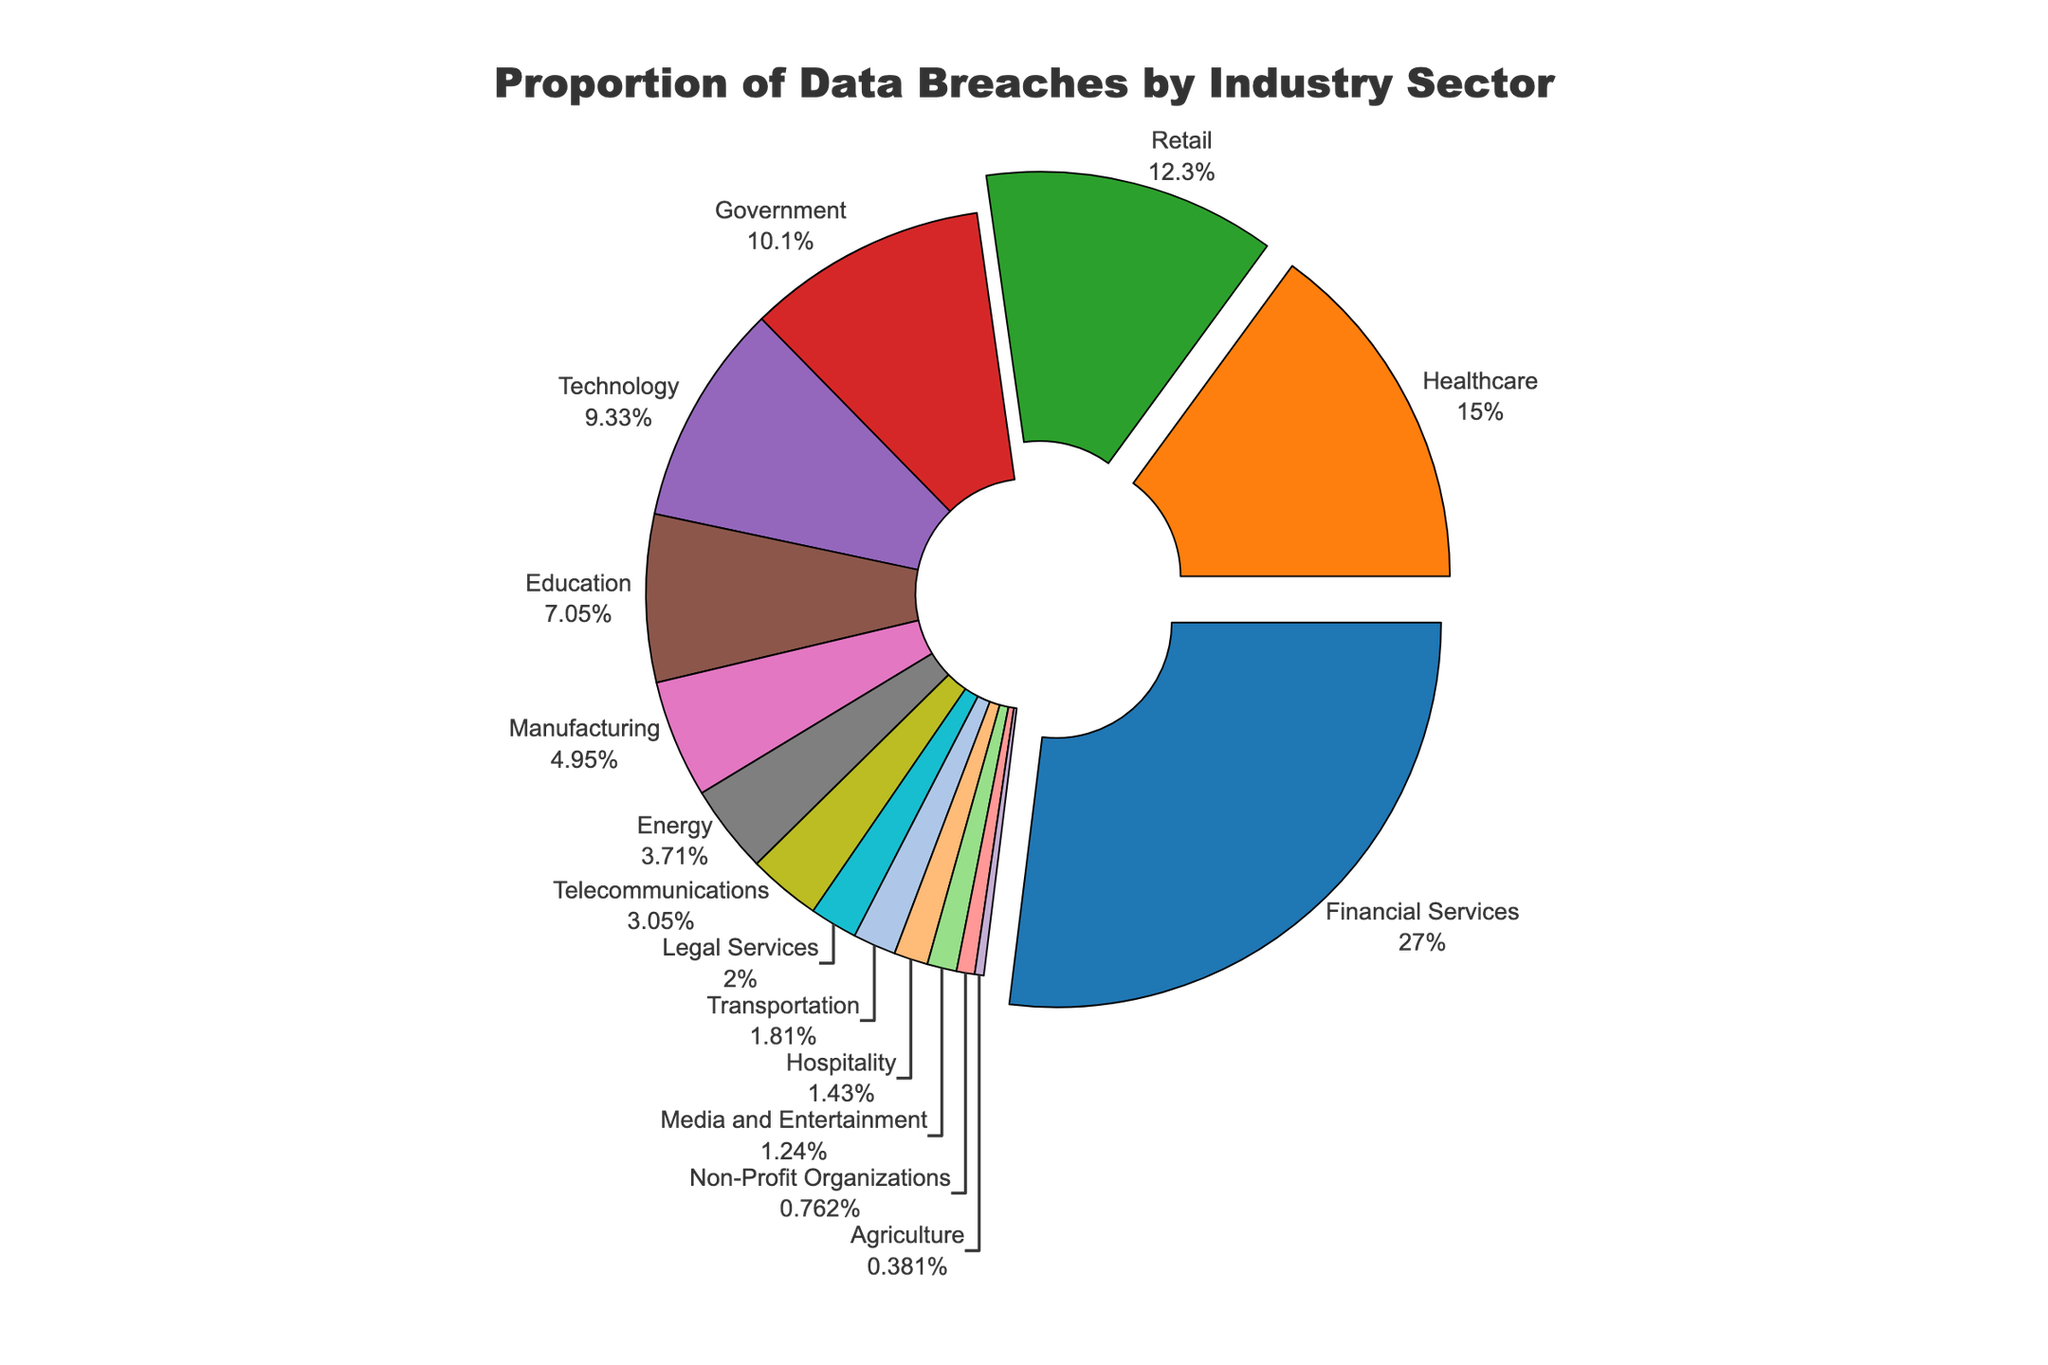What percentage of data breaches occurred in the Retail sector? Identify the segment labeled as "Retail" in the pie chart and read the percentage value associated with it.
Answer: 12.9% Which industry sector has the highest proportion of data breaches, and what is the percentage? Find the largest segment in the pie chart, labeled as "Financial Services," and read the percentage value associated with it.
Answer: Financial Services, 28.3% How do the proportions of data breaches in the Healthcare and Government sectors compare? Identify the segments labeled "Healthcare" and "Government," then compare their percentage values (Healthcare: 15.7%, Government: 10.6%).
Answer: Healthcare has a higher proportion than Government What is the combined percentage of data breaches in the Technology and Manufacturing sectors? Identify the segments labeled "Technology" and "Manufacturing" and sum their percentage values (Technology: 9.8%, Manufacturing: 5.2%). 9.8 + 5.2 = 15.0
Answer: 15.0% Which three sectors have been pulled out for emphasis in the pie chart? Look for the segments that are visually separated from the pie chart (popped out). These are "Financial Services," "Healthcare," and "Retail."
Answer: Financial Services, Healthcare, Retail What is the difference in the proportion of data breaches between the Financial Services and Energy sectors? Subtract the percentage of Energy (3.9%) from the percentage of Financial Services (28.3%). 28.3 - 3.9 = 24.4
Answer: 24.4% What is the combined percentage of data breaches in sectors with more than 10% each? Add the percentages of sectors with more than 10%: Financial Services (28.3%), Healthcare (15.7%), Retail (12.9%), and Government (10.6%). 28.3 + 15.7 + 12.9 + 10.6 = 67.5
Answer: 67.5% What is the smallest sector in terms of data breach proportion, and what is its percentage? Find the smallest segment in the pie chart, labeled "Agriculture," and read the percentage value associated with it.
Answer: Agriculture, 0.4% How much larger is the proportion of data breaches in the Education sector compared to the Telecommunications sector? Subtract the percentage of Telecommunications (3.2%) from the percentage of Education (7.4%). 7.4 - 3.2 = 4.2
Answer: 4.2% How do the proportions of data breaches in the Legal Services and Transportation sectors compare visually? Compare the sizes of the segments labeled "Legal Services" and "Transportation"; Legal Services is slightly larger.
Answer: Legal Services is larger than Transportation 